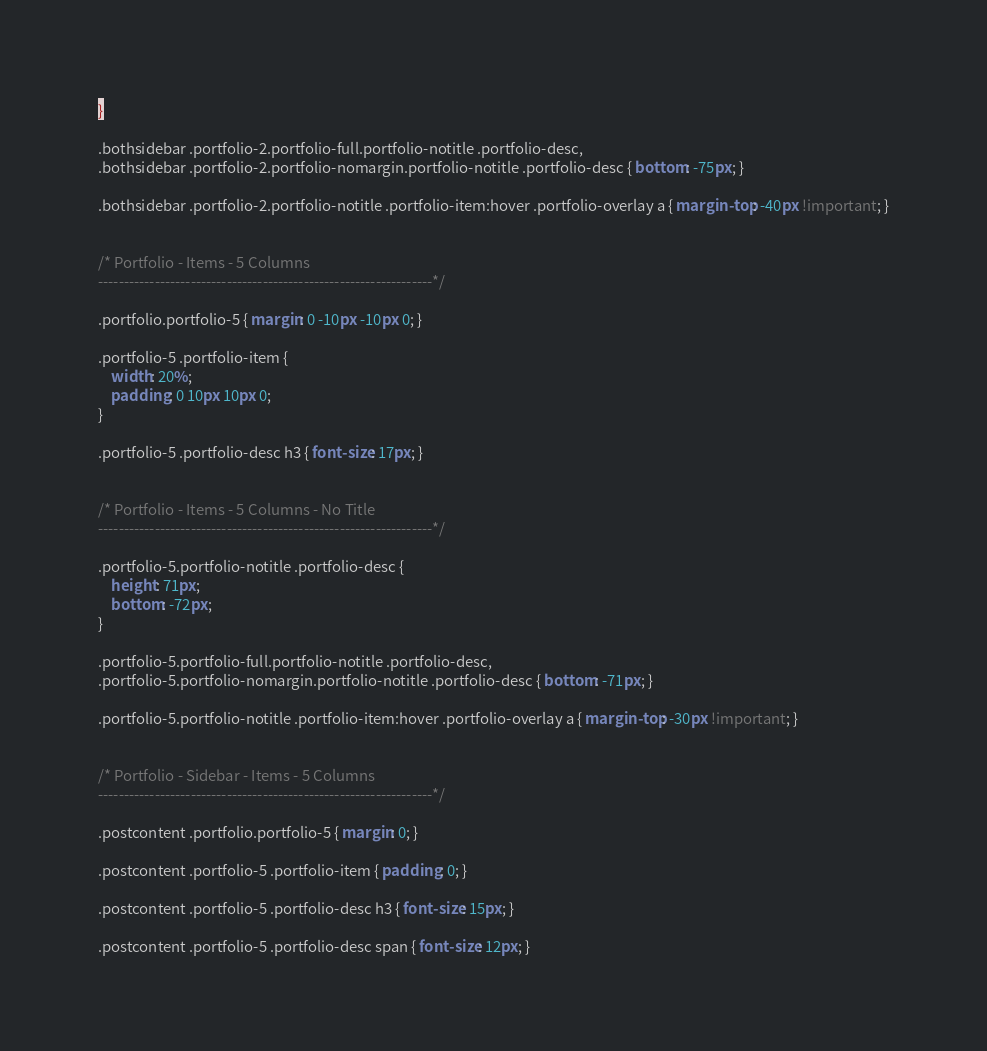<code> <loc_0><loc_0><loc_500><loc_500><_CSS_>}

.bothsidebar .portfolio-2.portfolio-full.portfolio-notitle .portfolio-desc,
.bothsidebar .portfolio-2.portfolio-nomargin.portfolio-notitle .portfolio-desc { bottom: -75px; }

.bothsidebar .portfolio-2.portfolio-notitle .portfolio-item:hover .portfolio-overlay a { margin-top: -40px !important; }


/* Portfolio - Items - 5 Columns
-----------------------------------------------------------------*/

.portfolio.portfolio-5 { margin: 0 -10px -10px 0; }

.portfolio-5 .portfolio-item {
	width: 20%;
	padding: 0 10px 10px 0;
}

.portfolio-5 .portfolio-desc h3 { font-size: 17px; }


/* Portfolio - Items - 5 Columns - No Title
-----------------------------------------------------------------*/

.portfolio-5.portfolio-notitle .portfolio-desc {
	height: 71px;
	bottom: -72px;
}

.portfolio-5.portfolio-full.portfolio-notitle .portfolio-desc,
.portfolio-5.portfolio-nomargin.portfolio-notitle .portfolio-desc { bottom: -71px; }

.portfolio-5.portfolio-notitle .portfolio-item:hover .portfolio-overlay a { margin-top: -30px !important; }


/* Portfolio - Sidebar - Items - 5 Columns
-----------------------------------------------------------------*/

.postcontent .portfolio.portfolio-5 { margin: 0; }

.postcontent .portfolio-5 .portfolio-item { padding: 0; }

.postcontent .portfolio-5 .portfolio-desc h3 { font-size: 15px; }

.postcontent .portfolio-5 .portfolio-desc span { font-size: 12px; }
</code> 